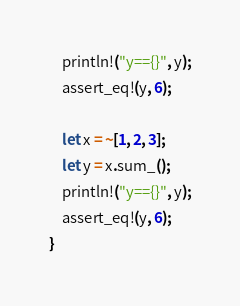Convert code to text. <code><loc_0><loc_0><loc_500><loc_500><_Rust_>    println!("y=={}", y);
    assert_eq!(y, 6);

    let x = ~[1, 2, 3];
    let y = x.sum_();
    println!("y=={}", y);
    assert_eq!(y, 6);
}
</code> 